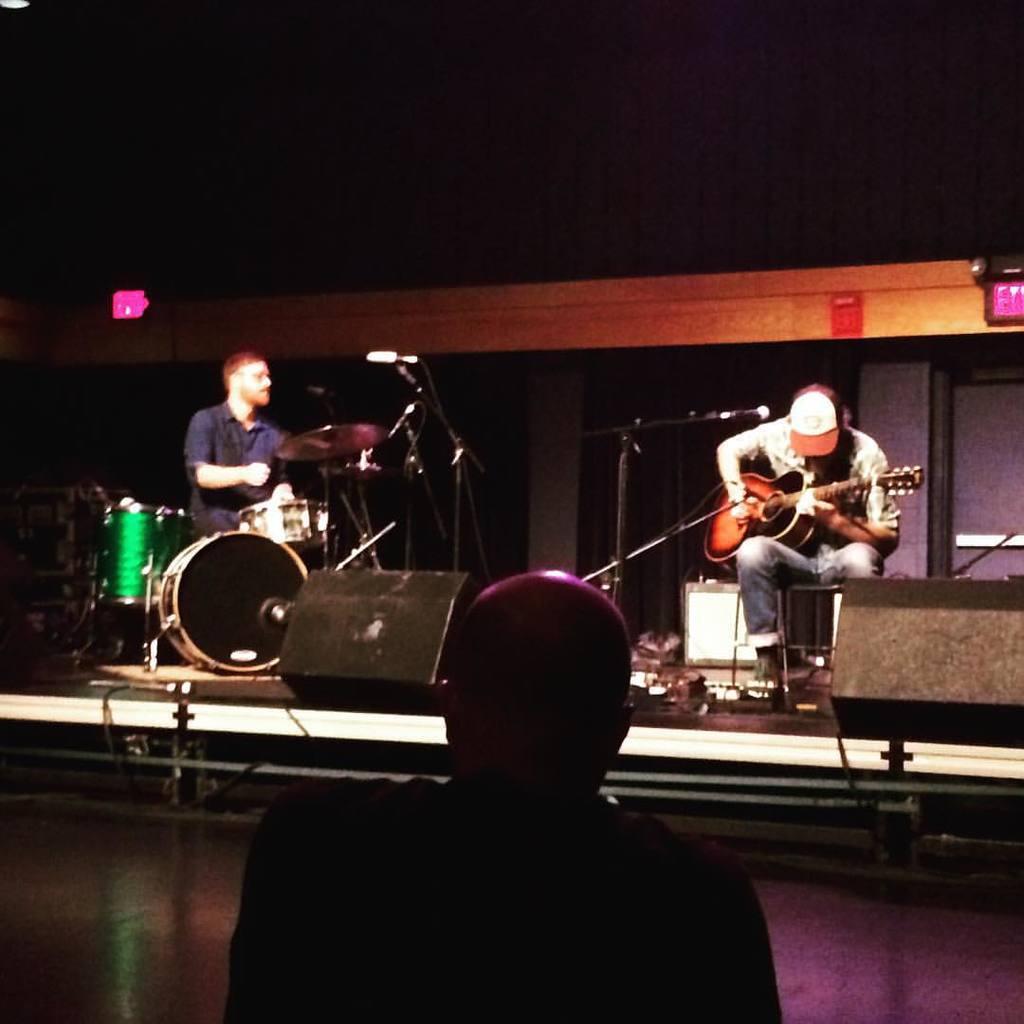Describe this image in one or two sentences. This image is clicked in a concert. There are three men in this image. On the dais there are two men performing music. To the right, the man is playing guitar. To the left, the man is playing drums. In the background, there is a wall. 